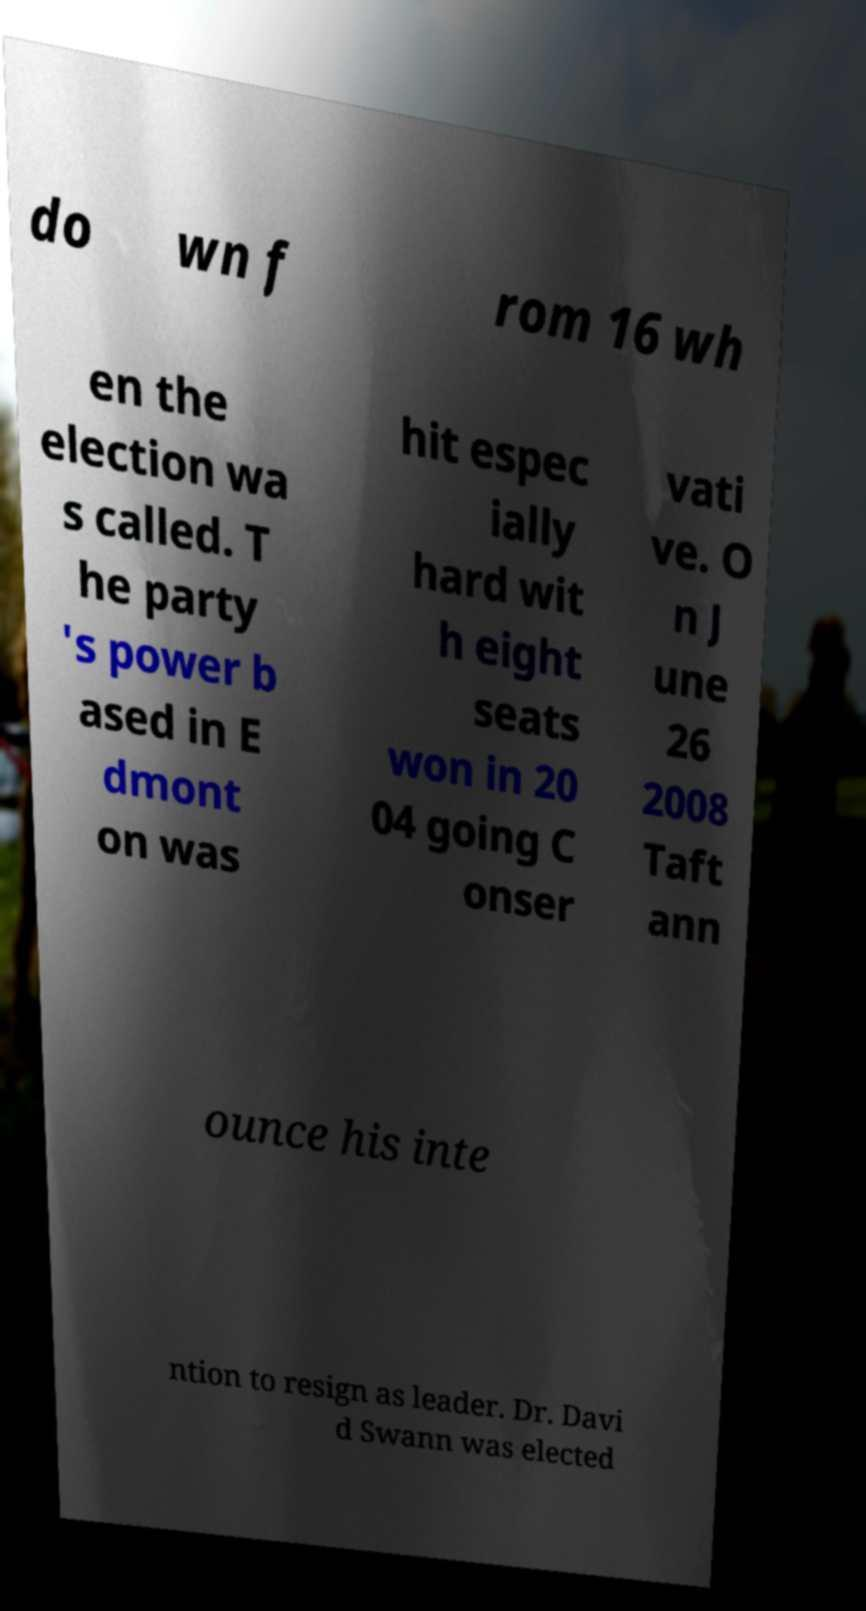For documentation purposes, I need the text within this image transcribed. Could you provide that? do wn f rom 16 wh en the election wa s called. T he party 's power b ased in E dmont on was hit espec ially hard wit h eight seats won in 20 04 going C onser vati ve. O n J une 26 2008 Taft ann ounce his inte ntion to resign as leader. Dr. Davi d Swann was elected 